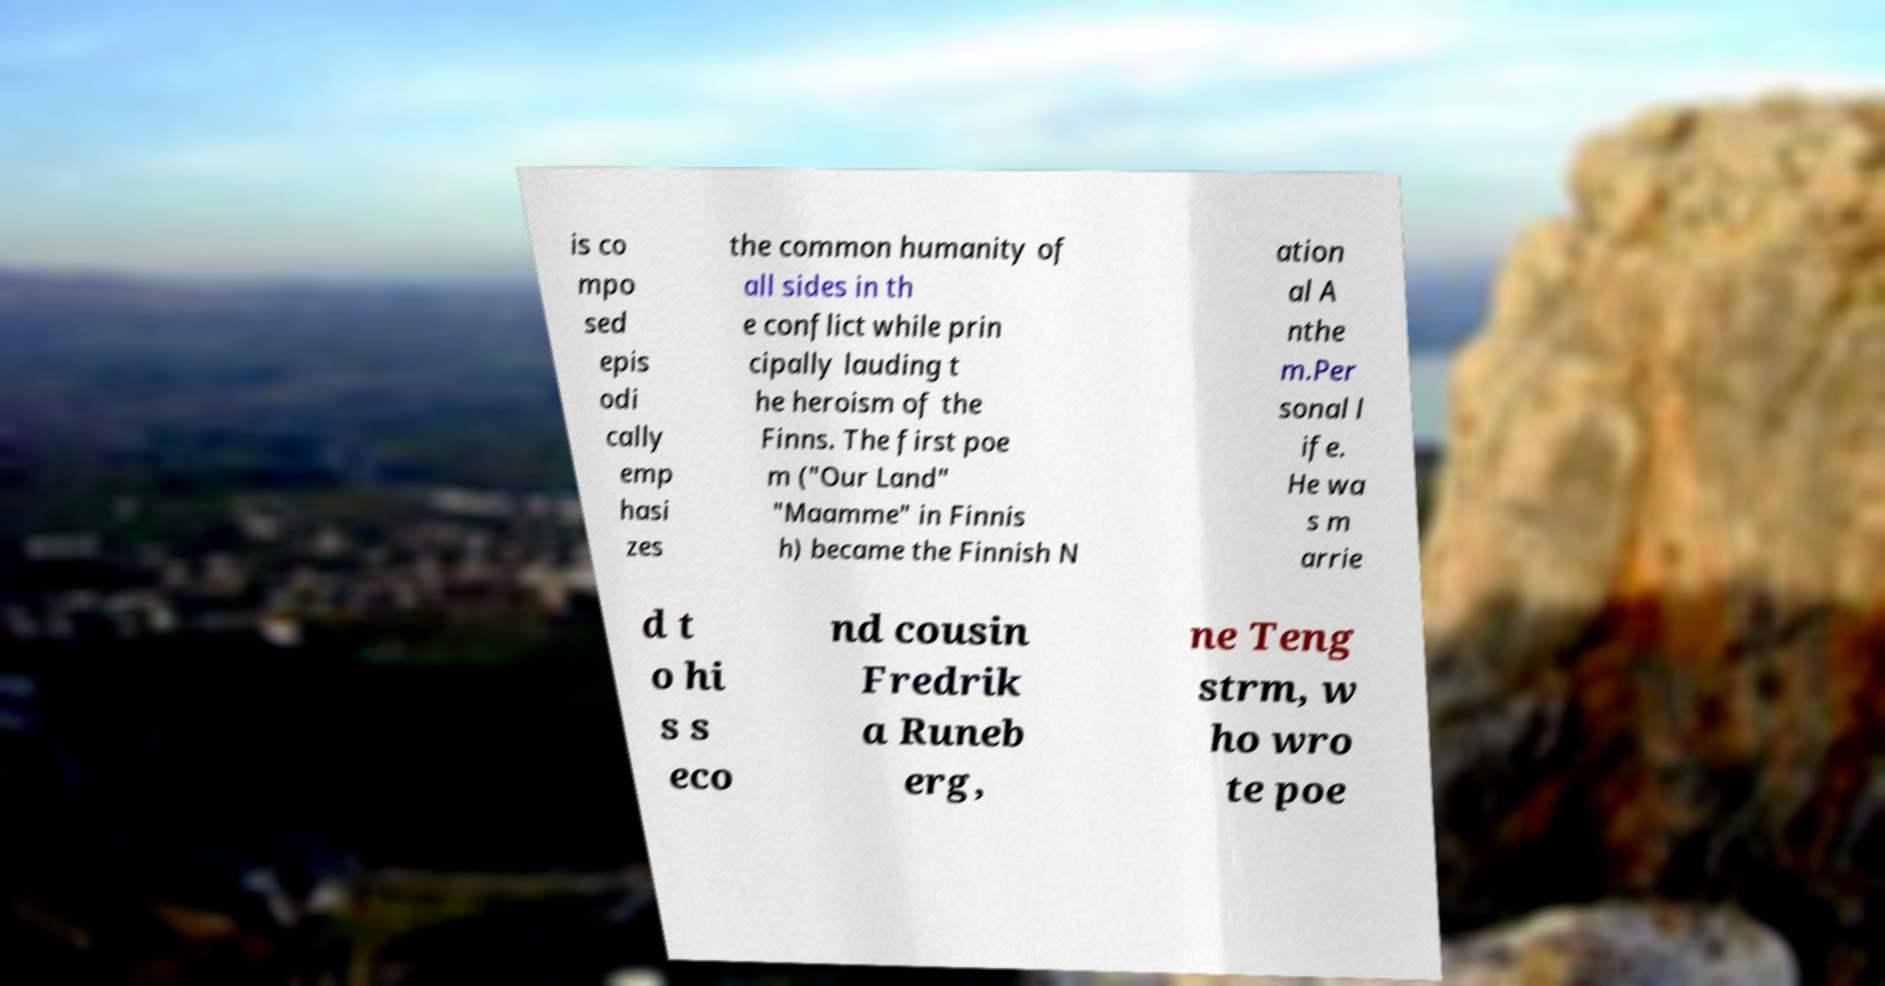Could you extract and type out the text from this image? is co mpo sed epis odi cally emp hasi zes the common humanity of all sides in th e conflict while prin cipally lauding t he heroism of the Finns. The first poe m ("Our Land" "Maamme" in Finnis h) became the Finnish N ation al A nthe m.Per sonal l ife. He wa s m arrie d t o hi s s eco nd cousin Fredrik a Runeb erg, ne Teng strm, w ho wro te poe 